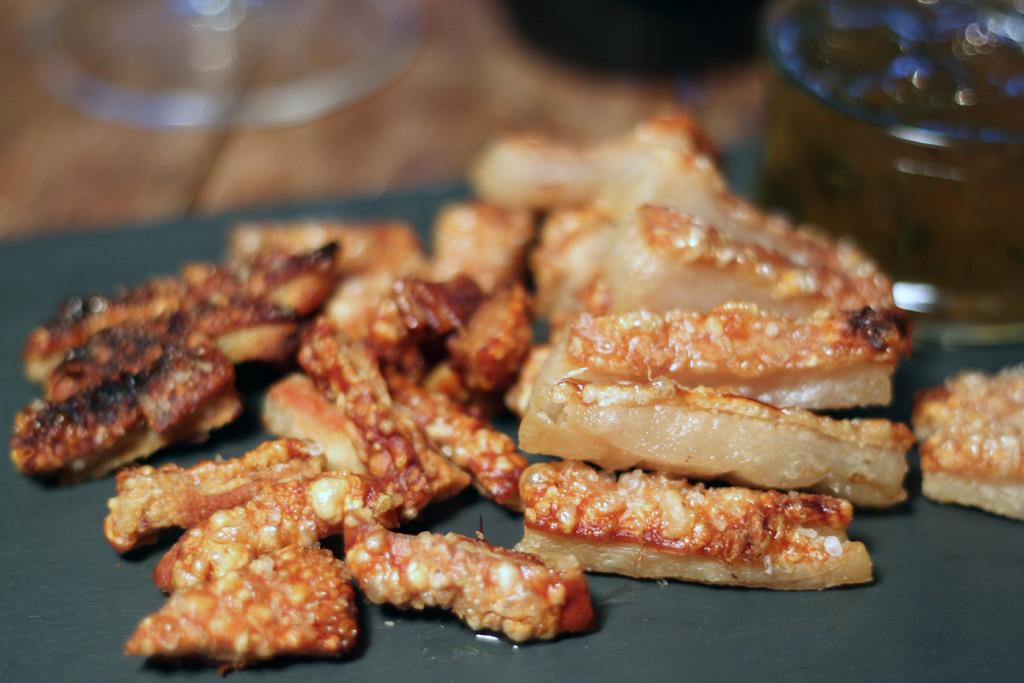What is present on the surface in the image? There is food placed on a surface in the image. What else can be seen at the top of the image? There are glasses visible at the top of the image. What type of print can be seen on the rabbit in the image? There is no rabbit present in the image, so there is no print to observe. 